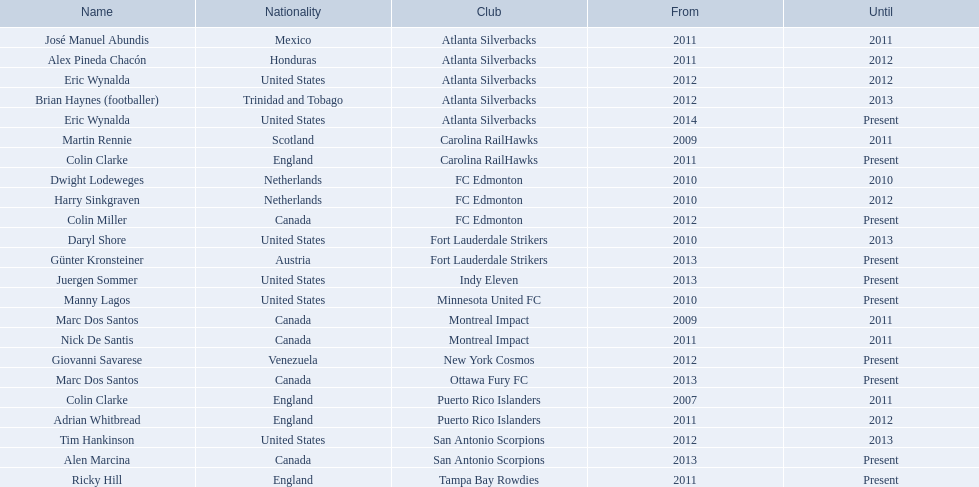In which year did marc dos santos begin his coaching career? 2009. Which other commencement years match this year? 2009. Who was the other coach with this initiation year? Martin Rennie. 